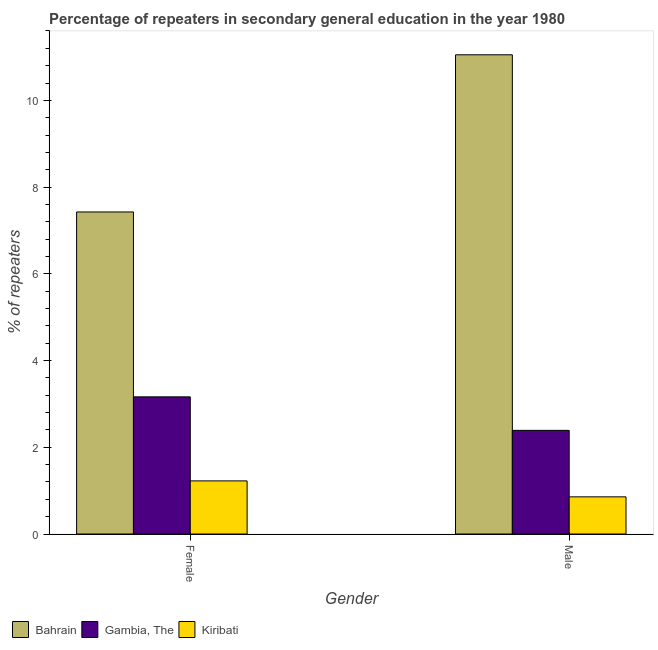How many different coloured bars are there?
Give a very brief answer. 3. Are the number of bars on each tick of the X-axis equal?
Make the answer very short. Yes. How many bars are there on the 2nd tick from the left?
Offer a very short reply. 3. How many bars are there on the 1st tick from the right?
Your answer should be very brief. 3. What is the percentage of male repeaters in Gambia, The?
Offer a terse response. 2.39. Across all countries, what is the maximum percentage of female repeaters?
Keep it short and to the point. 7.43. Across all countries, what is the minimum percentage of female repeaters?
Provide a short and direct response. 1.22. In which country was the percentage of male repeaters maximum?
Make the answer very short. Bahrain. In which country was the percentage of male repeaters minimum?
Provide a succinct answer. Kiribati. What is the total percentage of male repeaters in the graph?
Give a very brief answer. 14.3. What is the difference between the percentage of female repeaters in Kiribati and that in Gambia, The?
Your response must be concise. -1.94. What is the difference between the percentage of male repeaters in Gambia, The and the percentage of female repeaters in Bahrain?
Keep it short and to the point. -5.04. What is the average percentage of female repeaters per country?
Offer a terse response. 3.94. What is the difference between the percentage of female repeaters and percentage of male repeaters in Gambia, The?
Your answer should be very brief. 0.77. In how many countries, is the percentage of male repeaters greater than 6 %?
Ensure brevity in your answer.  1. What is the ratio of the percentage of female repeaters in Bahrain to that in Gambia, The?
Offer a terse response. 2.35. In how many countries, is the percentage of female repeaters greater than the average percentage of female repeaters taken over all countries?
Your response must be concise. 1. What does the 1st bar from the left in Female represents?
Provide a succinct answer. Bahrain. What does the 3rd bar from the right in Male represents?
Provide a succinct answer. Bahrain. Are all the bars in the graph horizontal?
Provide a short and direct response. No. Does the graph contain any zero values?
Provide a succinct answer. No. Where does the legend appear in the graph?
Offer a very short reply. Bottom left. How many legend labels are there?
Offer a very short reply. 3. What is the title of the graph?
Your answer should be compact. Percentage of repeaters in secondary general education in the year 1980. What is the label or title of the Y-axis?
Ensure brevity in your answer.  % of repeaters. What is the % of repeaters in Bahrain in Female?
Your answer should be compact. 7.43. What is the % of repeaters of Gambia, The in Female?
Give a very brief answer. 3.16. What is the % of repeaters in Kiribati in Female?
Ensure brevity in your answer.  1.22. What is the % of repeaters in Bahrain in Male?
Your answer should be compact. 11.05. What is the % of repeaters of Gambia, The in Male?
Provide a succinct answer. 2.39. What is the % of repeaters of Kiribati in Male?
Provide a short and direct response. 0.86. Across all Gender, what is the maximum % of repeaters in Bahrain?
Give a very brief answer. 11.05. Across all Gender, what is the maximum % of repeaters of Gambia, The?
Offer a very short reply. 3.16. Across all Gender, what is the maximum % of repeaters in Kiribati?
Your response must be concise. 1.22. Across all Gender, what is the minimum % of repeaters in Bahrain?
Give a very brief answer. 7.43. Across all Gender, what is the minimum % of repeaters in Gambia, The?
Ensure brevity in your answer.  2.39. Across all Gender, what is the minimum % of repeaters of Kiribati?
Offer a terse response. 0.86. What is the total % of repeaters of Bahrain in the graph?
Ensure brevity in your answer.  18.48. What is the total % of repeaters in Gambia, The in the graph?
Offer a terse response. 5.55. What is the total % of repeaters of Kiribati in the graph?
Offer a very short reply. 2.08. What is the difference between the % of repeaters of Bahrain in Female and that in Male?
Give a very brief answer. -3.62. What is the difference between the % of repeaters of Gambia, The in Female and that in Male?
Provide a short and direct response. 0.77. What is the difference between the % of repeaters in Kiribati in Female and that in Male?
Your answer should be very brief. 0.37. What is the difference between the % of repeaters of Bahrain in Female and the % of repeaters of Gambia, The in Male?
Give a very brief answer. 5.04. What is the difference between the % of repeaters in Bahrain in Female and the % of repeaters in Kiribati in Male?
Provide a short and direct response. 6.57. What is the difference between the % of repeaters of Gambia, The in Female and the % of repeaters of Kiribati in Male?
Provide a succinct answer. 2.31. What is the average % of repeaters of Bahrain per Gender?
Provide a succinct answer. 9.24. What is the average % of repeaters in Gambia, The per Gender?
Your answer should be very brief. 2.78. What is the average % of repeaters of Kiribati per Gender?
Make the answer very short. 1.04. What is the difference between the % of repeaters in Bahrain and % of repeaters in Gambia, The in Female?
Provide a succinct answer. 4.26. What is the difference between the % of repeaters in Bahrain and % of repeaters in Kiribati in Female?
Offer a terse response. 6.2. What is the difference between the % of repeaters in Gambia, The and % of repeaters in Kiribati in Female?
Provide a short and direct response. 1.94. What is the difference between the % of repeaters in Bahrain and % of repeaters in Gambia, The in Male?
Ensure brevity in your answer.  8.66. What is the difference between the % of repeaters in Bahrain and % of repeaters in Kiribati in Male?
Offer a terse response. 10.19. What is the difference between the % of repeaters in Gambia, The and % of repeaters in Kiribati in Male?
Make the answer very short. 1.53. What is the ratio of the % of repeaters in Bahrain in Female to that in Male?
Keep it short and to the point. 0.67. What is the ratio of the % of repeaters in Gambia, The in Female to that in Male?
Your response must be concise. 1.32. What is the ratio of the % of repeaters of Kiribati in Female to that in Male?
Give a very brief answer. 1.43. What is the difference between the highest and the second highest % of repeaters of Bahrain?
Keep it short and to the point. 3.62. What is the difference between the highest and the second highest % of repeaters in Gambia, The?
Offer a terse response. 0.77. What is the difference between the highest and the second highest % of repeaters in Kiribati?
Your answer should be compact. 0.37. What is the difference between the highest and the lowest % of repeaters of Bahrain?
Your response must be concise. 3.62. What is the difference between the highest and the lowest % of repeaters of Gambia, The?
Provide a succinct answer. 0.77. What is the difference between the highest and the lowest % of repeaters in Kiribati?
Offer a very short reply. 0.37. 